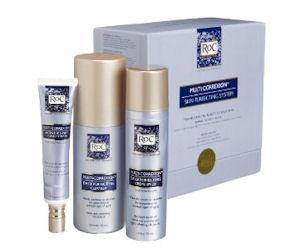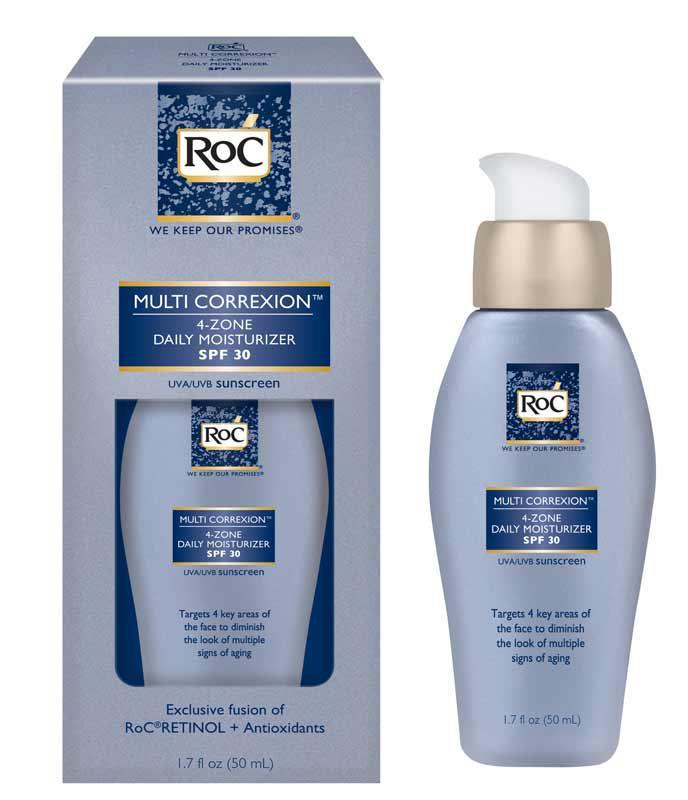The first image is the image on the left, the second image is the image on the right. Assess this claim about the two images: "Each image depicts one skincare product next to its box.". Correct or not? Answer yes or no. No. The first image is the image on the left, the second image is the image on the right. Analyze the images presented: Is the assertion "In each image, exactly one product is beside its box." valid? Answer yes or no. No. 